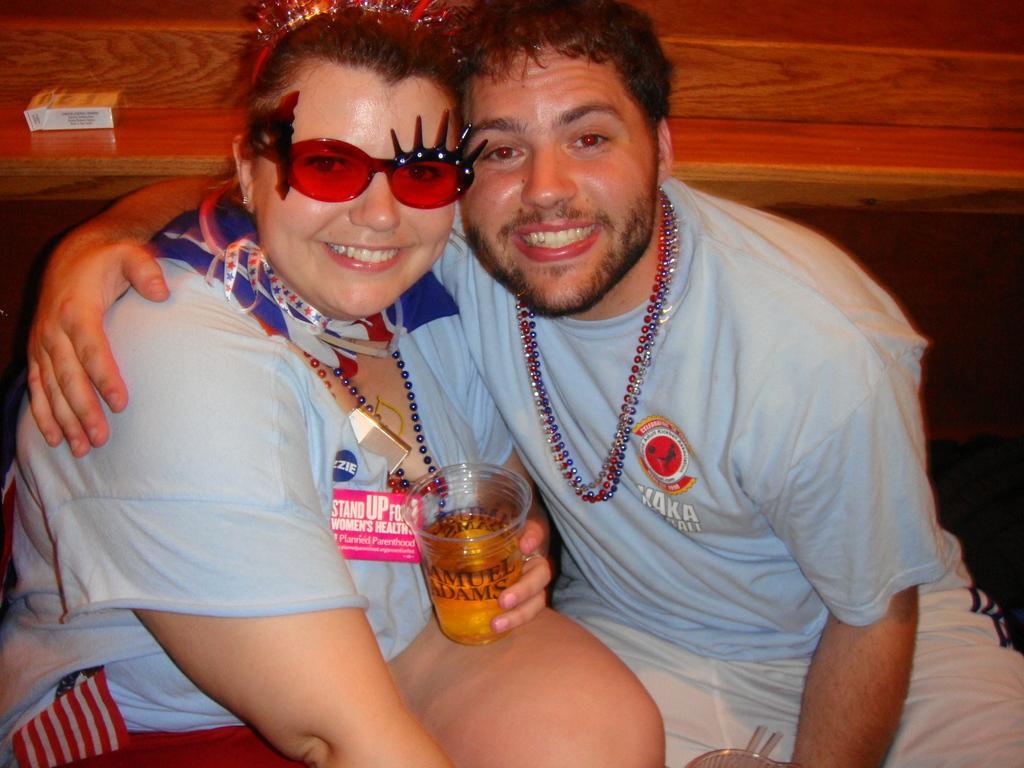Can you describe this image briefly? In this image I can see a woman wearing grey t shirt and a man wearing t shirt and white short are sitting and smiling. I can see the woman is holding a glass in her hand. In the background I can see a desk on which I can see a cigarette packet. 